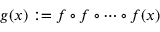Convert formula to latex. <formula><loc_0><loc_0><loc_500><loc_500>g ( x ) \colon = f \circ f \circ \cdots \circ f ( x )</formula> 